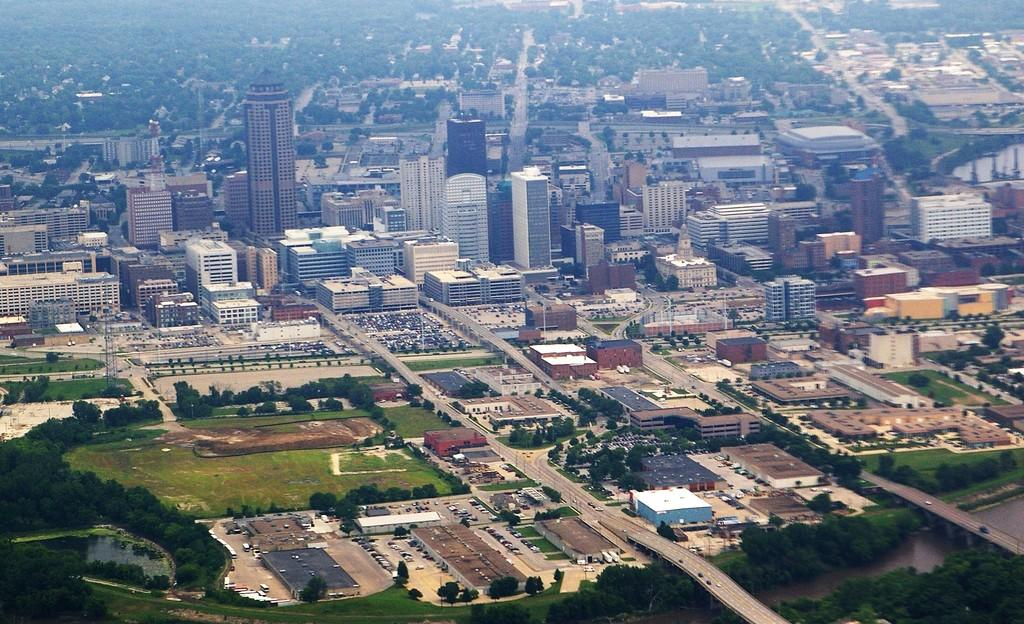What types of structures can be seen in the image? There are buildings and houses in the image. What type of vegetation is present in the image? There are trees, plants, and grass in the image. What type of transportation is visible in the image? There are vehicles in the image. What type of infrastructure is present in the image? There are roads and bridges in the image. What natural element can be seen in the image? There is water visible in the image. How many cherries are hanging from the trees in the image? There are no cherries present in the image; only trees, plants, and grass are visible. What is the level of noise in the image? The image does not provide any information about the noise level, as it is a still image. 